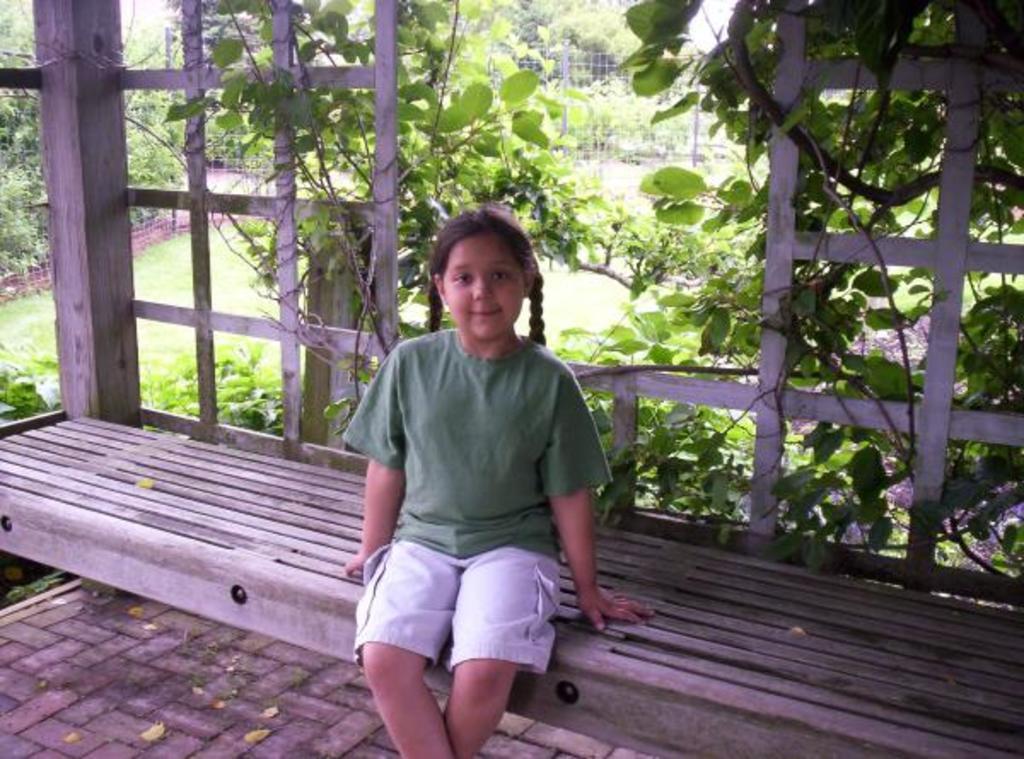Could you give a brief overview of what you see in this image? In the picture there is a girl sitting on the bench and laughing, behind her there are many trees, there are creeps, there are plants, there is an iron fence. 